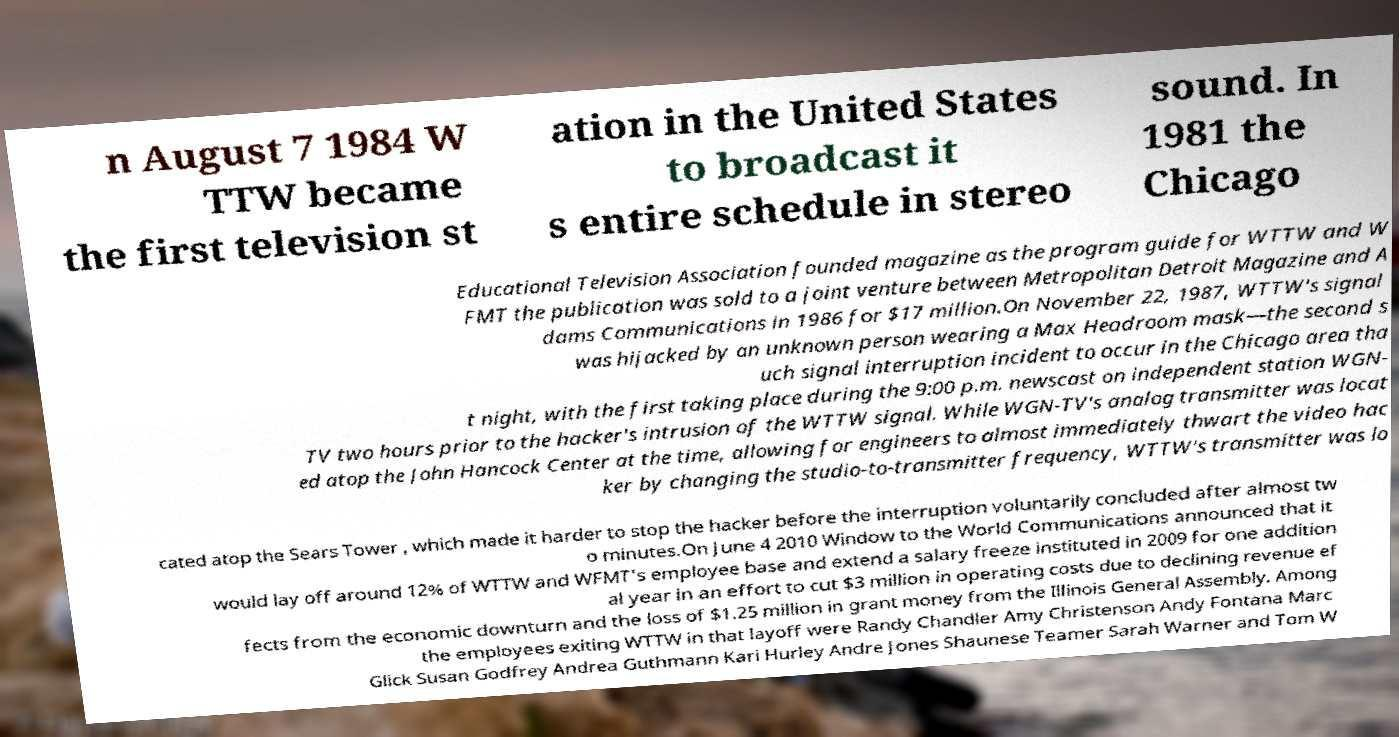There's text embedded in this image that I need extracted. Can you transcribe it verbatim? n August 7 1984 W TTW became the first television st ation in the United States to broadcast it s entire schedule in stereo sound. In 1981 the Chicago Educational Television Association founded magazine as the program guide for WTTW and W FMT the publication was sold to a joint venture between Metropolitan Detroit Magazine and A dams Communications in 1986 for $17 million.On November 22, 1987, WTTW's signal was hijacked by an unknown person wearing a Max Headroom mask—the second s uch signal interruption incident to occur in the Chicago area tha t night, with the first taking place during the 9:00 p.m. newscast on independent station WGN- TV two hours prior to the hacker's intrusion of the WTTW signal. While WGN-TV's analog transmitter was locat ed atop the John Hancock Center at the time, allowing for engineers to almost immediately thwart the video hac ker by changing the studio-to-transmitter frequency, WTTW's transmitter was lo cated atop the Sears Tower , which made it harder to stop the hacker before the interruption voluntarily concluded after almost tw o minutes.On June 4 2010 Window to the World Communications announced that it would lay off around 12% of WTTW and WFMT's employee base and extend a salary freeze instituted in 2009 for one addition al year in an effort to cut $3 million in operating costs due to declining revenue ef fects from the economic downturn and the loss of $1.25 million in grant money from the Illinois General Assembly. Among the employees exiting WTTW in that layoff were Randy Chandler Amy Christenson Andy Fontana Marc Glick Susan Godfrey Andrea Guthmann Kari Hurley Andre Jones Shaunese Teamer Sarah Warner and Tom W 